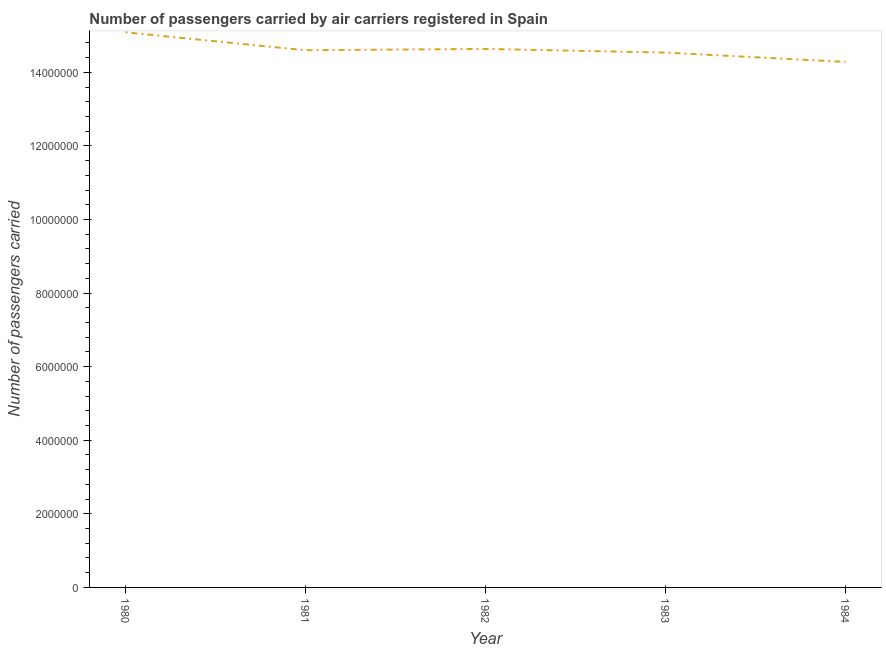What is the number of passengers carried in 1980?
Your response must be concise. 1.51e+07. Across all years, what is the maximum number of passengers carried?
Give a very brief answer. 1.51e+07. Across all years, what is the minimum number of passengers carried?
Make the answer very short. 1.43e+07. What is the sum of the number of passengers carried?
Ensure brevity in your answer.  7.32e+07. What is the difference between the number of passengers carried in 1983 and 1984?
Offer a very short reply. 2.54e+05. What is the average number of passengers carried per year?
Offer a terse response. 1.46e+07. What is the median number of passengers carried?
Keep it short and to the point. 1.46e+07. Do a majority of the years between 1982 and 1980 (inclusive) have number of passengers carried greater than 11600000 ?
Provide a succinct answer. No. What is the ratio of the number of passengers carried in 1981 to that in 1983?
Provide a short and direct response. 1. What is the difference between the highest and the second highest number of passengers carried?
Your answer should be compact. 4.51e+05. Is the sum of the number of passengers carried in 1981 and 1984 greater than the maximum number of passengers carried across all years?
Offer a very short reply. Yes. What is the difference between the highest and the lowest number of passengers carried?
Your answer should be very brief. 8.05e+05. What is the difference between two consecutive major ticks on the Y-axis?
Ensure brevity in your answer.  2.00e+06. Are the values on the major ticks of Y-axis written in scientific E-notation?
Provide a succinct answer. No. Does the graph contain any zero values?
Give a very brief answer. No. Does the graph contain grids?
Your answer should be compact. No. What is the title of the graph?
Your response must be concise. Number of passengers carried by air carriers registered in Spain. What is the label or title of the Y-axis?
Your answer should be very brief. Number of passengers carried. What is the Number of passengers carried of 1980?
Provide a succinct answer. 1.51e+07. What is the Number of passengers carried of 1981?
Your answer should be very brief. 1.46e+07. What is the Number of passengers carried in 1982?
Keep it short and to the point. 1.46e+07. What is the Number of passengers carried in 1983?
Give a very brief answer. 1.45e+07. What is the Number of passengers carried of 1984?
Provide a succinct answer. 1.43e+07. What is the difference between the Number of passengers carried in 1980 and 1981?
Your answer should be compact. 4.87e+05. What is the difference between the Number of passengers carried in 1980 and 1982?
Your response must be concise. 4.51e+05. What is the difference between the Number of passengers carried in 1980 and 1983?
Provide a succinct answer. 5.51e+05. What is the difference between the Number of passengers carried in 1980 and 1984?
Give a very brief answer. 8.05e+05. What is the difference between the Number of passengers carried in 1981 and 1982?
Your answer should be compact. -3.58e+04. What is the difference between the Number of passengers carried in 1981 and 1983?
Your answer should be compact. 6.38e+04. What is the difference between the Number of passengers carried in 1981 and 1984?
Make the answer very short. 3.18e+05. What is the difference between the Number of passengers carried in 1982 and 1983?
Offer a very short reply. 9.96e+04. What is the difference between the Number of passengers carried in 1982 and 1984?
Ensure brevity in your answer.  3.54e+05. What is the difference between the Number of passengers carried in 1983 and 1984?
Make the answer very short. 2.54e+05. What is the ratio of the Number of passengers carried in 1980 to that in 1981?
Provide a short and direct response. 1.03. What is the ratio of the Number of passengers carried in 1980 to that in 1982?
Keep it short and to the point. 1.03. What is the ratio of the Number of passengers carried in 1980 to that in 1983?
Your answer should be compact. 1.04. What is the ratio of the Number of passengers carried in 1980 to that in 1984?
Give a very brief answer. 1.06. What is the ratio of the Number of passengers carried in 1982 to that in 1983?
Your answer should be compact. 1.01. What is the ratio of the Number of passengers carried in 1982 to that in 1984?
Give a very brief answer. 1.02. What is the ratio of the Number of passengers carried in 1983 to that in 1984?
Make the answer very short. 1.02. 